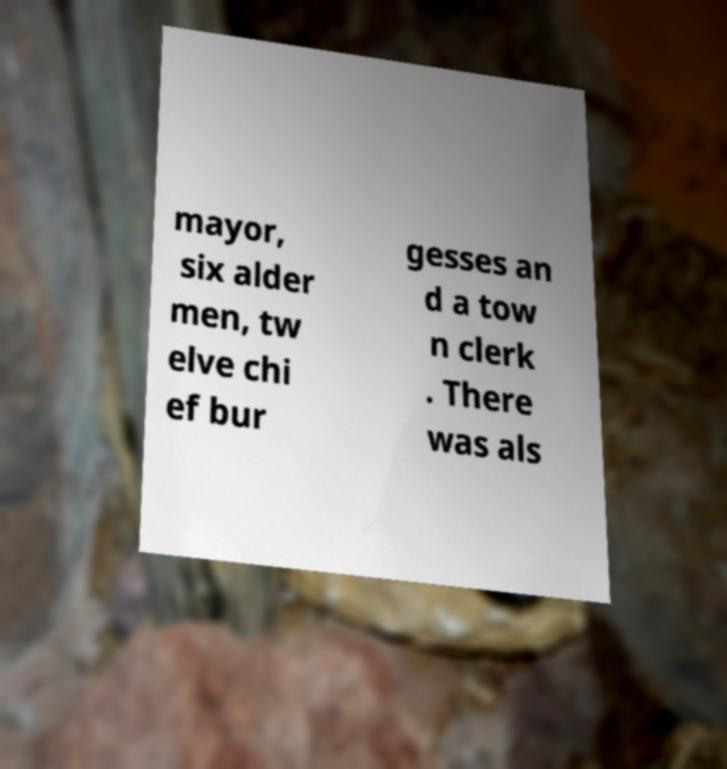Please identify and transcribe the text found in this image. mayor, six alder men, tw elve chi ef bur gesses an d a tow n clerk . There was als 